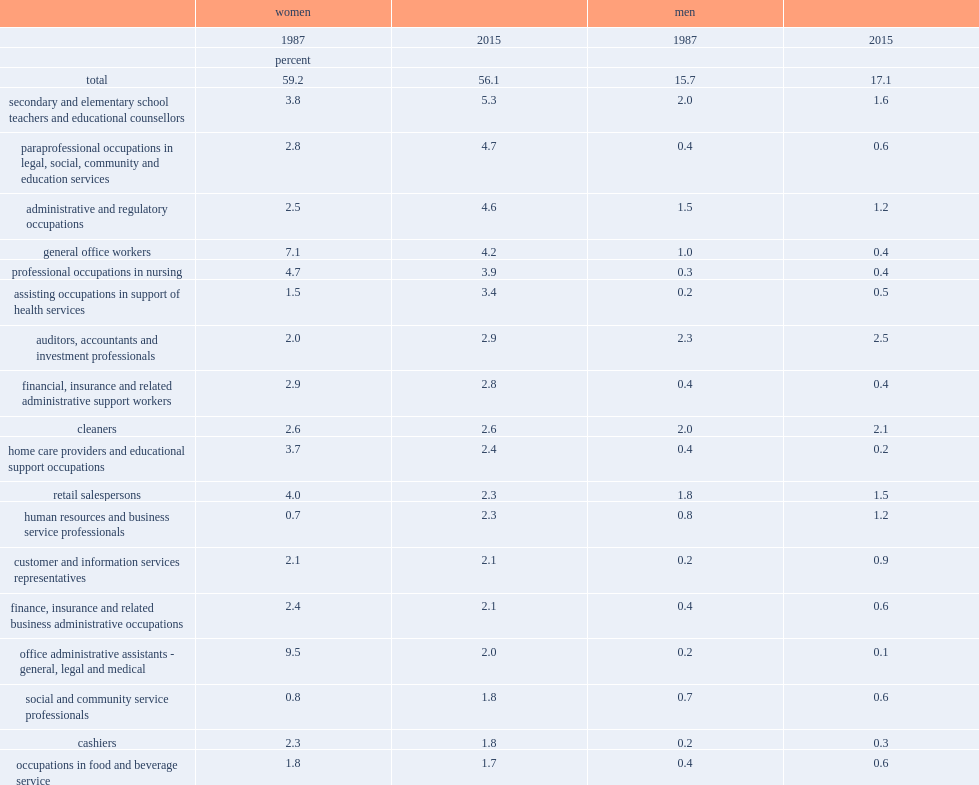Which gender has a greater proportion overall in the 20 occupations? Women. In which year is the proportion of women in 20 occupations overall greater than men in the same jobs? 2015.0. What's the percentage of women that were employed in occupations involving the "5 cs" in 2015? 56.1. What's the percentage of women that were employed in occupations involving the "5 cs" in 1987? 59.2. Which year has a greater proportion of women employed in occupations involving "5 cs", 1987 or 2015? 1987.0. What's the percentage of men employed in occupations like secondary and elementary school teachers and educational counsellors in 2015? 17.1. What's the percentage of men employed in occupations like secondary and elementary school teachers and educational counsellors in 1987? 15.7. Which year has a greater proportion of men employed in traditionally-female occupations, 2015 or 1987? 2015.0. Would you be able to parse every entry in this table? {'header': ['', 'women', '', 'men', ''], 'rows': [['', '1987', '2015', '1987', '2015'], ['', 'percent', '', '', ''], ['total', '59.2', '56.1', '15.7', '17.1'], ['secondary and elementary school teachers and educational counsellors', '3.8', '5.3', '2.0', '1.6'], ['paraprofessional occupations in legal, social, community and education services', '2.8', '4.7', '0.4', '0.6'], ['administrative and regulatory occupations', '2.5', '4.6', '1.5', '1.2'], ['general office workers', '7.1', '4.2', '1.0', '0.4'], ['professional occupations in nursing', '4.7', '3.9', '0.3', '0.4'], ['assisting occupations in support of health services', '1.5', '3.4', '0.2', '0.5'], ['auditors, accountants and investment professionals', '2.0', '2.9', '2.3', '2.5'], ['financial, insurance and related administrative support workers', '2.9', '2.8', '0.4', '0.4'], ['cleaners', '2.6', '2.6', '2.0', '2.1'], ['home care providers and educational support occupations', '3.7', '2.4', '0.4', '0.2'], ['retail salespersons', '4.0', '2.3', '1.8', '1.5'], ['human resources and business service professionals', '0.7', '2.3', '0.8', '1.2'], ['customer and information services representatives', '2.1', '2.1', '0.2', '0.9'], ['finance, insurance and related business administrative occupations', '2.4', '2.1', '0.4', '0.6'], ['office administrative assistants - general, legal and medical', '9.5', '2.0', '0.2', '0.1'], ['social and community service professionals', '0.8', '1.8', '0.7', '0.6'], ['cashiers', '2.3', '1.8', '0.2', '0.3'], ['occupations in food and beverage service', '1.8', '1.7', '0.4', '0.6'], ['policy and program researchers, consultants and officers', '0.4', '1.7', '0.4', '1.0'], ['other technical occupations in health care', '1.7', '1.6', '0.2', '0.4']]} 